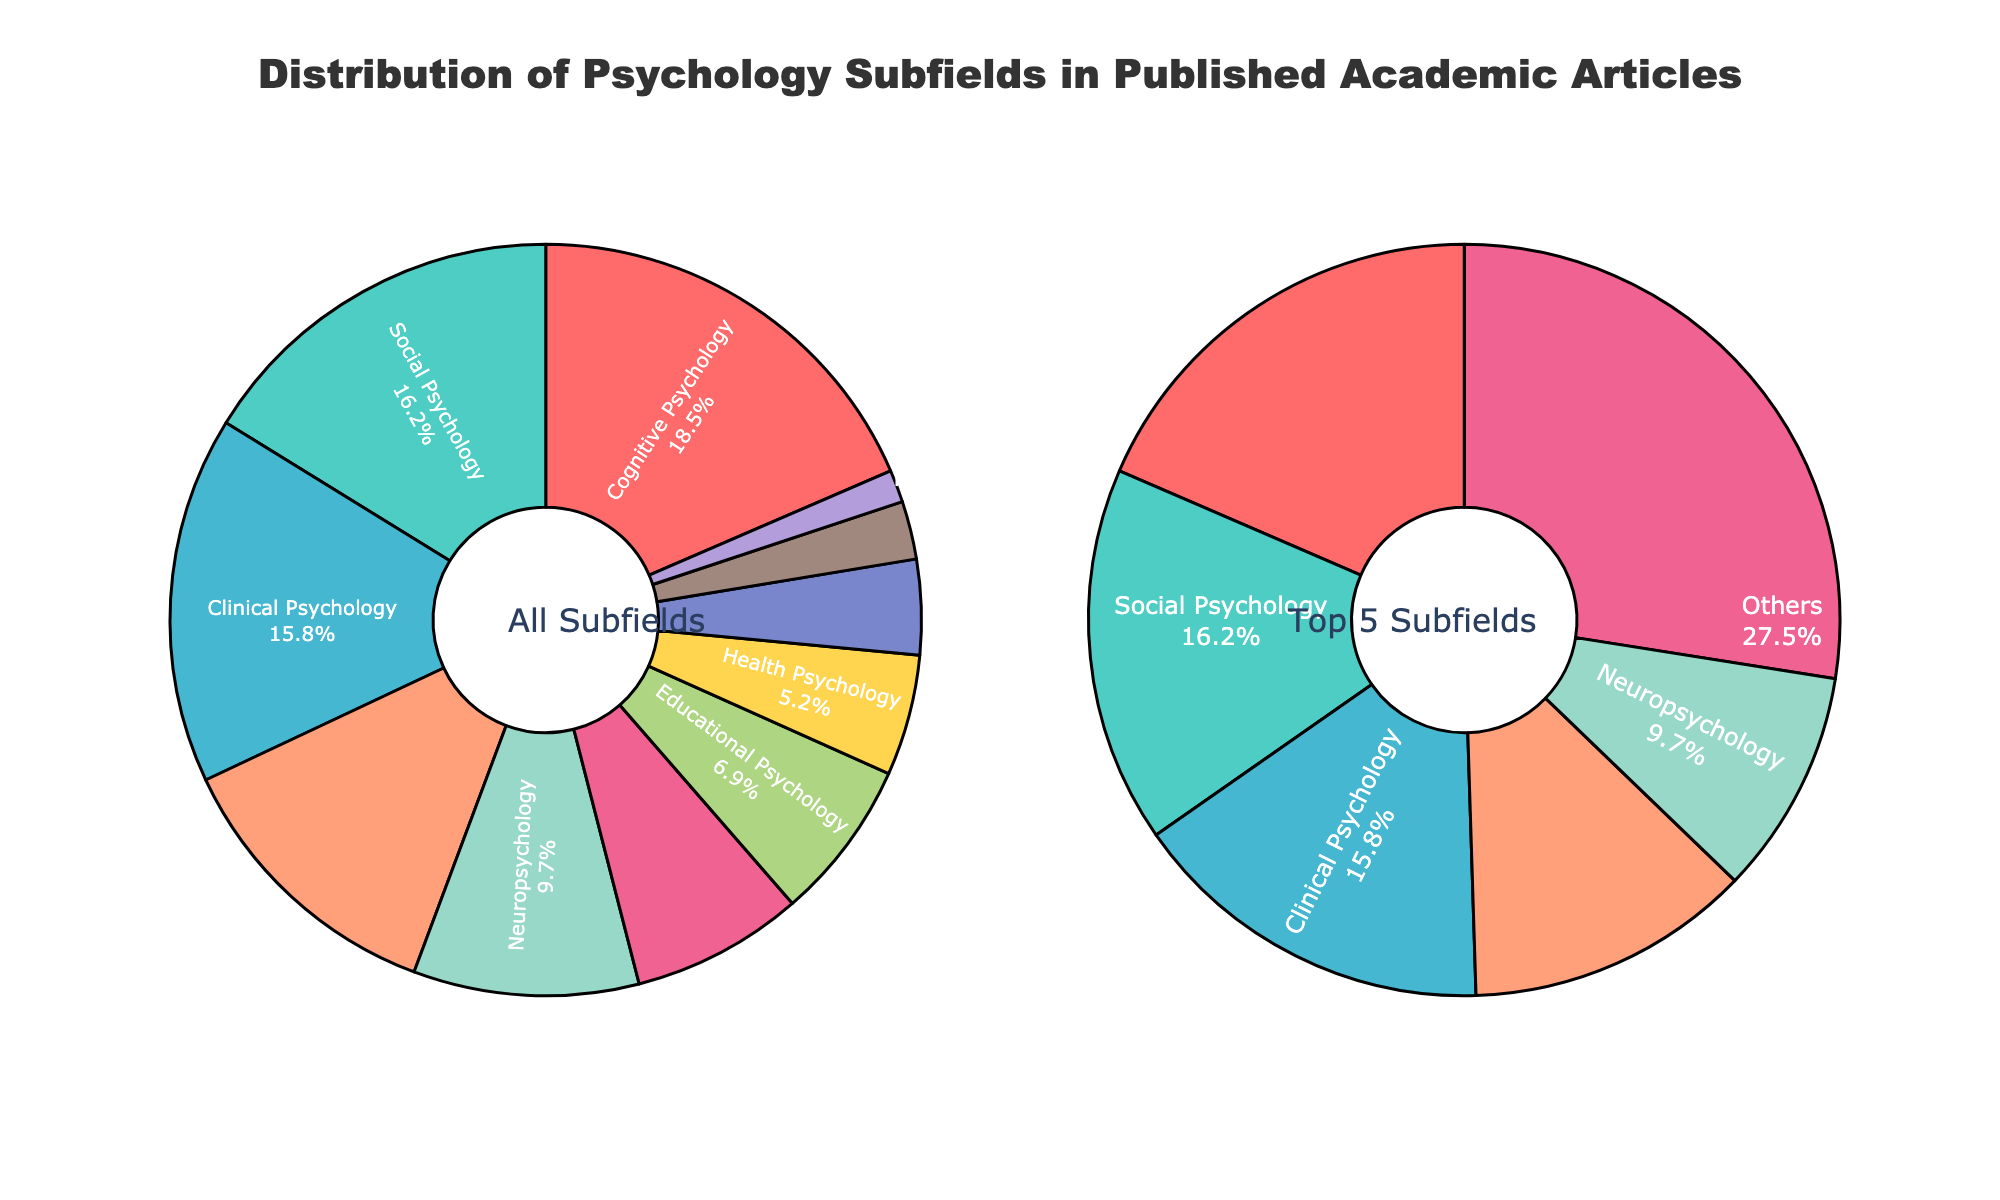What subfield has the largest percentage in published academic articles? The main pie chart's segments show that Cognitive Psychology has the largest percentage. The related label indicates it has 18.5%.
Answer: Cognitive Psychology What is the combined percentage of Clinical Psychology and Social Psychology? From the figure, Clinical Psychology is 15.8% and Social Psychology is 16.2%. Adding these gives 15.8 + 16.2.
Answer: 32% Which subfield appears smallest in terms of percentage, and what is its value? Positive Psychology has the smallest segment in the main pie chart, representing 1.4%.
Answer: Positive Psychology How does the percentage of Neuropsychology compare to that of Industrial-Organizational Psychology? Neuropsychology's percentage is 9.7%, while Industrial-Organizational Psychology's is 7.4%. Neuropsychology is greater.
Answer: Neuropsychology is greater What is the total percentage of all subfields that form the 'Others' category in the zoomed-in pie chart? In the zoomed-in pie chart, the 'Others' category includes all subfields except the top 5. Adding the subfields outside the top 5 from the main chart (Educational - 6.9%, Health - 5.2%, Forensic - 4.1%, Environmental - 2.5%, Positive - 1.4%) gives 6.9 + 5.2 + 4.1 + 2.5 + 1.4.
Answer: 20.1% Which subfields are included in the zoomed-in pie chart's top 5 subfields? The zoomed-in pie chart shows the top 5 subfields based on highest percentages. These are Cognitive Psychology, Social Psychology, Clinical Psychology, Developmental Psychology, and Neuropsychology.
Answer: Cognitive, Social, Clinical, Developmental, Neuropsychology What is the percentage difference between the largest and smallest subfields in the main pie chart? The largest subfield (Cognitive Psychology) is 18.5% and the smallest subfield (Positive Psychology) is 1.4%. Subtracting these gives 18.5 - 1.4.
Answer: 17.1% What proportion of the total does Clinical Psychology contribute to? Clinical Psychology's segment in the main pie chart indicates it contributes 15.8%.
Answer: 15.8% Based on the colors, which subfield is represented by green in the main pie chart? In the main pie chart, the green segment represents Clinical Psychology.
Answer: Clinical Psychology What are the second and third largest subfields, and their corresponding percentages? The main pie chart shows Social Psychology as the second largest at 16.2% and Clinical Psychology as the third largest at 15.8%.
Answer: Social Psychology (16.2%) and Clinical Psychology (15.8%) 